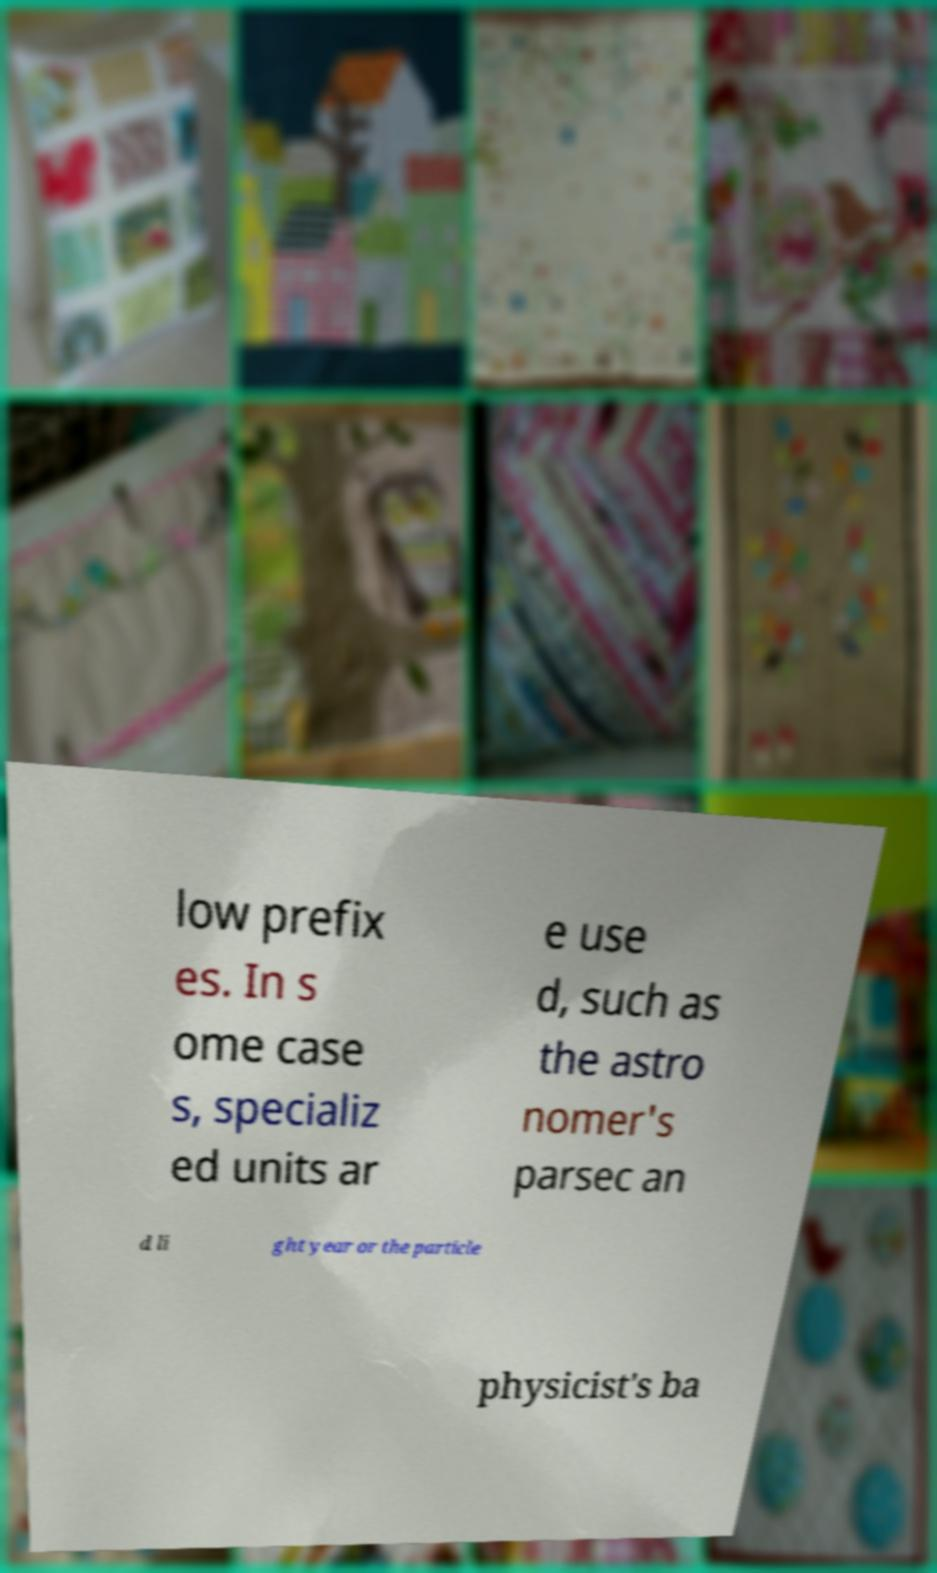Please identify and transcribe the text found in this image. low prefix es. In s ome case s, specializ ed units ar e use d, such as the astro nomer's parsec an d li ght year or the particle physicist's ba 